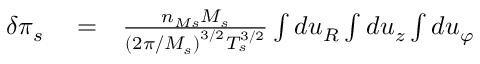Convert formula to latex. <formula><loc_0><loc_0><loc_500><loc_500>\begin{array} { r l r } { \delta \pi _ { s } } & = } & { \frac { n _ { M s } M _ { s } } { \left ( 2 \pi / M _ { s } \right ) ^ { 3 / 2 } T _ { s } ^ { 3 / 2 } } \int d u _ { R } \int d u _ { z } \int d u _ { \varphi } } \end{array}</formula> 